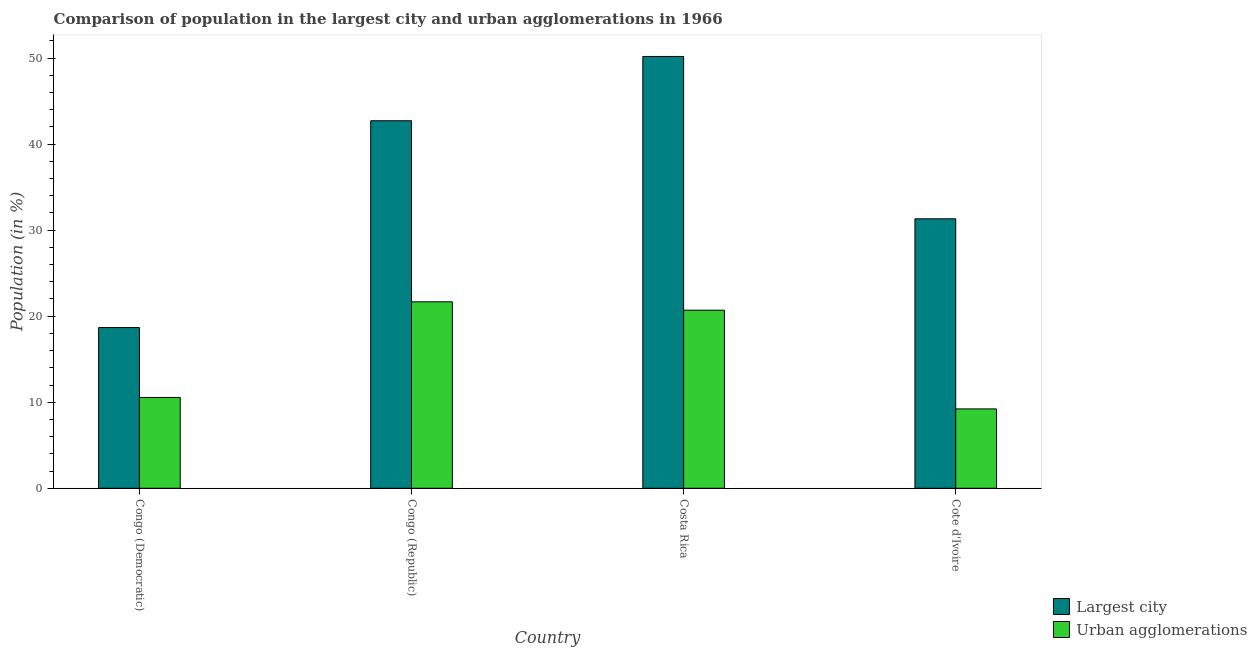How many groups of bars are there?
Your answer should be very brief. 4. Are the number of bars on each tick of the X-axis equal?
Give a very brief answer. Yes. How many bars are there on the 3rd tick from the left?
Your answer should be very brief. 2. What is the label of the 1st group of bars from the left?
Provide a succinct answer. Congo (Democratic). What is the population in the largest city in Cote d'Ivoire?
Offer a terse response. 31.32. Across all countries, what is the maximum population in urban agglomerations?
Ensure brevity in your answer.  21.67. Across all countries, what is the minimum population in the largest city?
Ensure brevity in your answer.  18.68. In which country was the population in the largest city maximum?
Provide a succinct answer. Costa Rica. In which country was the population in urban agglomerations minimum?
Give a very brief answer. Cote d'Ivoire. What is the total population in urban agglomerations in the graph?
Offer a very short reply. 62.16. What is the difference between the population in urban agglomerations in Congo (Democratic) and that in Congo (Republic)?
Your answer should be very brief. -11.12. What is the difference between the population in urban agglomerations in Congo (Republic) and the population in the largest city in Costa Rica?
Offer a terse response. -28.52. What is the average population in the largest city per country?
Your response must be concise. 35.73. What is the difference between the population in the largest city and population in urban agglomerations in Congo (Republic)?
Your answer should be very brief. 21.04. In how many countries, is the population in the largest city greater than 50 %?
Provide a succinct answer. 1. What is the ratio of the population in the largest city in Costa Rica to that in Cote d'Ivoire?
Provide a short and direct response. 1.6. Is the population in urban agglomerations in Congo (Democratic) less than that in Congo (Republic)?
Offer a terse response. Yes. Is the difference between the population in the largest city in Congo (Republic) and Costa Rica greater than the difference between the population in urban agglomerations in Congo (Republic) and Costa Rica?
Offer a terse response. No. What is the difference between the highest and the second highest population in urban agglomerations?
Make the answer very short. 0.97. What is the difference between the highest and the lowest population in the largest city?
Keep it short and to the point. 31.51. Is the sum of the population in urban agglomerations in Congo (Democratic) and Congo (Republic) greater than the maximum population in the largest city across all countries?
Ensure brevity in your answer.  No. What does the 2nd bar from the left in Congo (Democratic) represents?
Provide a succinct answer. Urban agglomerations. What does the 1st bar from the right in Congo (Democratic) represents?
Your answer should be compact. Urban agglomerations. How many countries are there in the graph?
Keep it short and to the point. 4. What is the difference between two consecutive major ticks on the Y-axis?
Offer a terse response. 10. Are the values on the major ticks of Y-axis written in scientific E-notation?
Your answer should be very brief. No. Does the graph contain grids?
Offer a terse response. No. What is the title of the graph?
Offer a terse response. Comparison of population in the largest city and urban agglomerations in 1966. What is the label or title of the X-axis?
Your answer should be compact. Country. What is the label or title of the Y-axis?
Give a very brief answer. Population (in %). What is the Population (in %) in Largest city in Congo (Democratic)?
Your answer should be compact. 18.68. What is the Population (in %) in Urban agglomerations in Congo (Democratic)?
Keep it short and to the point. 10.56. What is the Population (in %) of Largest city in Congo (Republic)?
Give a very brief answer. 42.72. What is the Population (in %) of Urban agglomerations in Congo (Republic)?
Make the answer very short. 21.67. What is the Population (in %) in Largest city in Costa Rica?
Offer a terse response. 50.19. What is the Population (in %) in Urban agglomerations in Costa Rica?
Offer a very short reply. 20.7. What is the Population (in %) in Largest city in Cote d'Ivoire?
Give a very brief answer. 31.32. What is the Population (in %) in Urban agglomerations in Cote d'Ivoire?
Offer a terse response. 9.23. Across all countries, what is the maximum Population (in %) in Largest city?
Offer a very short reply. 50.19. Across all countries, what is the maximum Population (in %) in Urban agglomerations?
Your response must be concise. 21.67. Across all countries, what is the minimum Population (in %) in Largest city?
Offer a very short reply. 18.68. Across all countries, what is the minimum Population (in %) in Urban agglomerations?
Your response must be concise. 9.23. What is the total Population (in %) of Largest city in the graph?
Your answer should be compact. 142.91. What is the total Population (in %) in Urban agglomerations in the graph?
Ensure brevity in your answer.  62.16. What is the difference between the Population (in %) of Largest city in Congo (Democratic) and that in Congo (Republic)?
Your response must be concise. -24.04. What is the difference between the Population (in %) in Urban agglomerations in Congo (Democratic) and that in Congo (Republic)?
Provide a succinct answer. -11.12. What is the difference between the Population (in %) in Largest city in Congo (Democratic) and that in Costa Rica?
Offer a terse response. -31.51. What is the difference between the Population (in %) of Urban agglomerations in Congo (Democratic) and that in Costa Rica?
Offer a very short reply. -10.14. What is the difference between the Population (in %) of Largest city in Congo (Democratic) and that in Cote d'Ivoire?
Give a very brief answer. -12.64. What is the difference between the Population (in %) of Urban agglomerations in Congo (Democratic) and that in Cote d'Ivoire?
Keep it short and to the point. 1.33. What is the difference between the Population (in %) of Largest city in Congo (Republic) and that in Costa Rica?
Offer a very short reply. -7.47. What is the difference between the Population (in %) of Urban agglomerations in Congo (Republic) and that in Costa Rica?
Keep it short and to the point. 0.97. What is the difference between the Population (in %) in Largest city in Congo (Republic) and that in Cote d'Ivoire?
Your answer should be compact. 11.4. What is the difference between the Population (in %) of Urban agglomerations in Congo (Republic) and that in Cote d'Ivoire?
Your answer should be compact. 12.45. What is the difference between the Population (in %) in Largest city in Costa Rica and that in Cote d'Ivoire?
Your answer should be very brief. 18.87. What is the difference between the Population (in %) of Urban agglomerations in Costa Rica and that in Cote d'Ivoire?
Your answer should be very brief. 11.47. What is the difference between the Population (in %) of Largest city in Congo (Democratic) and the Population (in %) of Urban agglomerations in Congo (Republic)?
Your response must be concise. -2.99. What is the difference between the Population (in %) of Largest city in Congo (Democratic) and the Population (in %) of Urban agglomerations in Costa Rica?
Give a very brief answer. -2.02. What is the difference between the Population (in %) in Largest city in Congo (Democratic) and the Population (in %) in Urban agglomerations in Cote d'Ivoire?
Your response must be concise. 9.45. What is the difference between the Population (in %) of Largest city in Congo (Republic) and the Population (in %) of Urban agglomerations in Costa Rica?
Your answer should be very brief. 22.02. What is the difference between the Population (in %) of Largest city in Congo (Republic) and the Population (in %) of Urban agglomerations in Cote d'Ivoire?
Your answer should be compact. 33.49. What is the difference between the Population (in %) of Largest city in Costa Rica and the Population (in %) of Urban agglomerations in Cote d'Ivoire?
Keep it short and to the point. 40.96. What is the average Population (in %) in Largest city per country?
Provide a short and direct response. 35.73. What is the average Population (in %) of Urban agglomerations per country?
Your response must be concise. 15.54. What is the difference between the Population (in %) in Largest city and Population (in %) in Urban agglomerations in Congo (Democratic)?
Provide a short and direct response. 8.12. What is the difference between the Population (in %) of Largest city and Population (in %) of Urban agglomerations in Congo (Republic)?
Give a very brief answer. 21.04. What is the difference between the Population (in %) of Largest city and Population (in %) of Urban agglomerations in Costa Rica?
Your answer should be compact. 29.49. What is the difference between the Population (in %) in Largest city and Population (in %) in Urban agglomerations in Cote d'Ivoire?
Offer a very short reply. 22.1. What is the ratio of the Population (in %) of Largest city in Congo (Democratic) to that in Congo (Republic)?
Give a very brief answer. 0.44. What is the ratio of the Population (in %) of Urban agglomerations in Congo (Democratic) to that in Congo (Republic)?
Keep it short and to the point. 0.49. What is the ratio of the Population (in %) in Largest city in Congo (Democratic) to that in Costa Rica?
Keep it short and to the point. 0.37. What is the ratio of the Population (in %) of Urban agglomerations in Congo (Democratic) to that in Costa Rica?
Make the answer very short. 0.51. What is the ratio of the Population (in %) of Largest city in Congo (Democratic) to that in Cote d'Ivoire?
Provide a short and direct response. 0.6. What is the ratio of the Population (in %) of Urban agglomerations in Congo (Democratic) to that in Cote d'Ivoire?
Make the answer very short. 1.14. What is the ratio of the Population (in %) in Largest city in Congo (Republic) to that in Costa Rica?
Your response must be concise. 0.85. What is the ratio of the Population (in %) in Urban agglomerations in Congo (Republic) to that in Costa Rica?
Make the answer very short. 1.05. What is the ratio of the Population (in %) of Largest city in Congo (Republic) to that in Cote d'Ivoire?
Provide a succinct answer. 1.36. What is the ratio of the Population (in %) of Urban agglomerations in Congo (Republic) to that in Cote d'Ivoire?
Offer a very short reply. 2.35. What is the ratio of the Population (in %) of Largest city in Costa Rica to that in Cote d'Ivoire?
Your answer should be very brief. 1.6. What is the ratio of the Population (in %) in Urban agglomerations in Costa Rica to that in Cote d'Ivoire?
Your answer should be very brief. 2.24. What is the difference between the highest and the second highest Population (in %) of Largest city?
Give a very brief answer. 7.47. What is the difference between the highest and the second highest Population (in %) of Urban agglomerations?
Your answer should be very brief. 0.97. What is the difference between the highest and the lowest Population (in %) in Largest city?
Your answer should be compact. 31.51. What is the difference between the highest and the lowest Population (in %) in Urban agglomerations?
Keep it short and to the point. 12.45. 